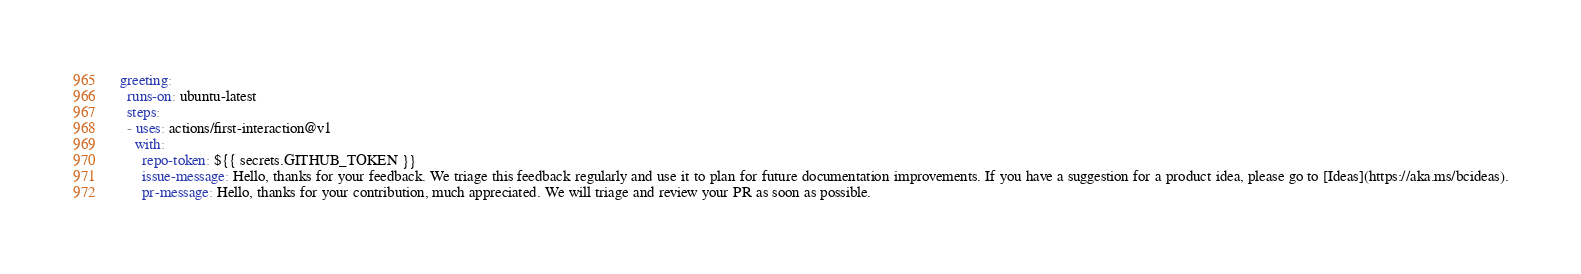Convert code to text. <code><loc_0><loc_0><loc_500><loc_500><_YAML_>  greeting:
    runs-on: ubuntu-latest
    steps:
    - uses: actions/first-interaction@v1
      with:
        repo-token: ${{ secrets.GITHUB_TOKEN }}
        issue-message: Hello, thanks for your feedback. We triage this feedback regularly and use it to plan for future documentation improvements. If you have a suggestion for a product idea, please go to [Ideas](https://aka.ms/bcideas).
        pr-message: Hello, thanks for your contribution, much appreciated. We will triage and review your PR as soon as possible.
</code> 